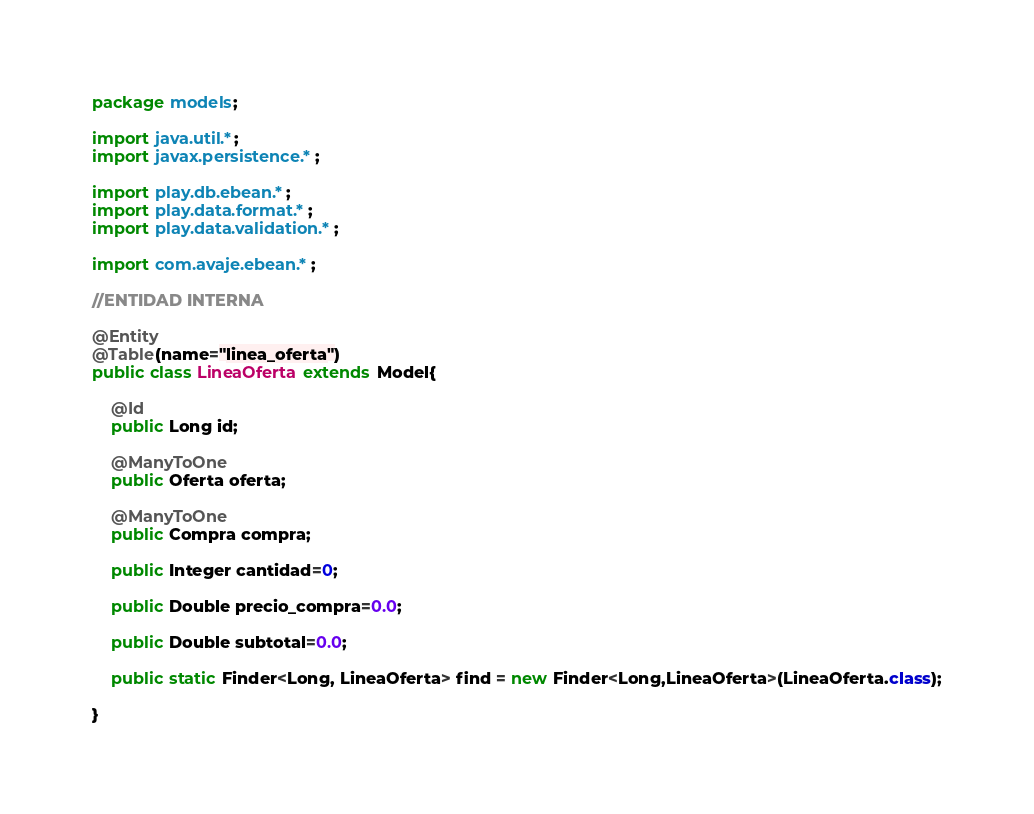Convert code to text. <code><loc_0><loc_0><loc_500><loc_500><_Java_>package models;

import java.util.*;
import javax.persistence.*;

import play.db.ebean.*;
import play.data.format.*;
import play.data.validation.*;

import com.avaje.ebean.*;

//ENTIDAD INTERNA

@Entity
@Table(name="linea_oferta")
public class LineaOferta extends Model{

	@Id
	public Long id;

	@ManyToOne
	public Oferta oferta;

	@ManyToOne
	public Compra compra;

	public Integer cantidad=0;

	public Double precio_compra=0.0;

	public Double subtotal=0.0;

    public static Finder<Long, LineaOferta> find = new Finder<Long,LineaOferta>(LineaOferta.class);

}</code> 